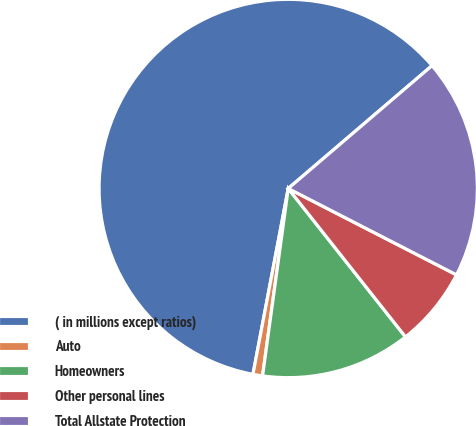Convert chart to OTSL. <chart><loc_0><loc_0><loc_500><loc_500><pie_chart><fcel>( in millions except ratios)<fcel>Auto<fcel>Homeowners<fcel>Other personal lines<fcel>Total Allstate Protection<nl><fcel>60.76%<fcel>0.82%<fcel>12.81%<fcel>6.81%<fcel>18.8%<nl></chart> 